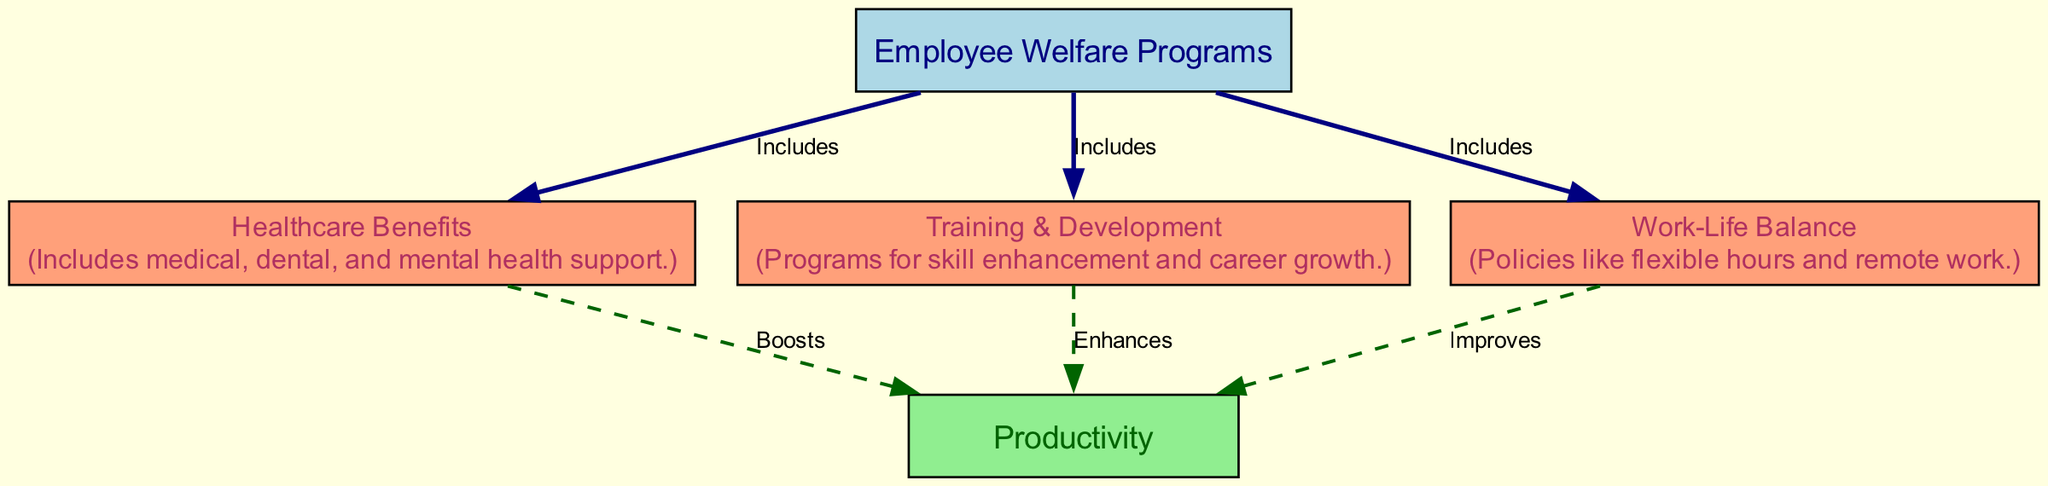What are the nodes connected to "Employee Welfare Programs"? The diagram indicates that "Employee Welfare Programs" is connected to three nodes: "Healthcare Benefits," "Training & Development," and "Work-Life Balance." This information is derived directly from the edges stemming from the "Employee Welfare Programs" node.
Answer: Healthcare Benefits, Training & Development, Work-Life Balance What relationship exists between "Healthcare Benefits" and "Productivity"? The diagram shows an edge labeled "Boosts" connecting "Healthcare Benefits" to "Productivity." This indicates a positive contribution of healthcare benefits to productivity levels.
Answer: Boosts How many edges are present in the diagram? By counting the lines that connect the nodes, we find a total of six edges. This can be tallied from both the connections from "Employee Welfare Programs" and the other specified relationships.
Answer: Six Which program is directly described as improving productivity? The diagram indicates that "Work-Life Balance" is described as improving productivity through its connection to the "Productivity" node.
Answer: Improves What kind of supports are included in "Healthcare Benefits"? The "Healthcare Benefits" node does not directly list items in the scatter plot but typically includes various types of support such as medical, dental, and mental health services as described under its details.
Answer: Medical, dental, and mental health support Which type of program enhances productivity according to the diagram? The "Training & Development" node is connected to "Productivity" with the label "Enhances," indicating that this type of program contributes positively to productivity levels.
Answer: Enhances How does "Training & Development" relate to employee welfare programs? The diagram shows that "Training & Development" is included in the overarching category of "Employee Welfare Programs,” highlighting its role in fostering employee well-being.
Answer: Includes What is the primary focus of "Employee Welfare Programs"? The node titled "Employee Welfare Programs" emphasizes initiatives that aim to improve employee well-being as its primary focus, summarizing the intent behind such programs.
Answer: Improving employee well-being 